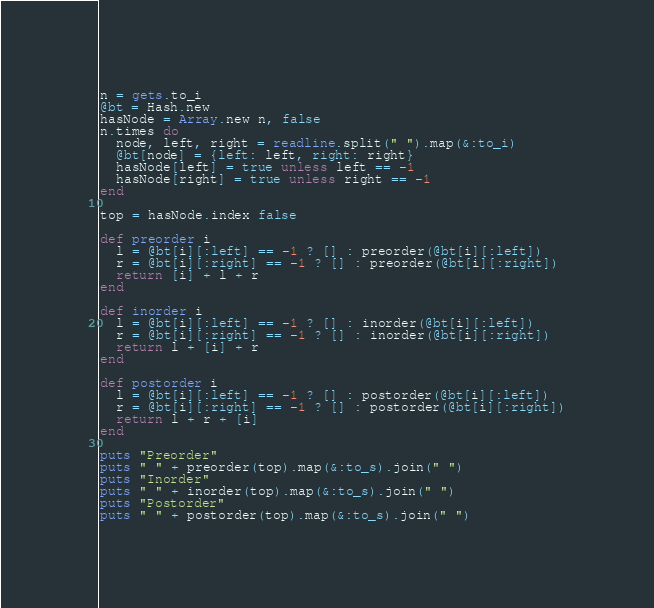Convert code to text. <code><loc_0><loc_0><loc_500><loc_500><_Ruby_>n = gets.to_i
@bt = Hash.new
hasNode = Array.new n, false
n.times do
  node, left, right = readline.split(" ").map(&:to_i)
  @bt[node] = {left: left, right: right}
  hasNode[left] = true unless left == -1
  hasNode[right] = true unless right == -1
end

top = hasNode.index false

def preorder i
  l = @bt[i][:left] == -1 ? [] : preorder(@bt[i][:left])
  r = @bt[i][:right] == -1 ? [] : preorder(@bt[i][:right])
  return [i] + l + r
end

def inorder i
  l = @bt[i][:left] == -1 ? [] : inorder(@bt[i][:left])
  r = @bt[i][:right] == -1 ? [] : inorder(@bt[i][:right])
  return l + [i] + r
end

def postorder i
  l = @bt[i][:left] == -1 ? [] : postorder(@bt[i][:left])
  r = @bt[i][:right] == -1 ? [] : postorder(@bt[i][:right])
  return l + r + [i]
end

puts "Preorder"
puts " " + preorder(top).map(&:to_s).join(" ")
puts "Inorder"
puts " " + inorder(top).map(&:to_s).join(" ")
puts "Postorder"
puts " " + postorder(top).map(&:to_s).join(" ")
</code> 